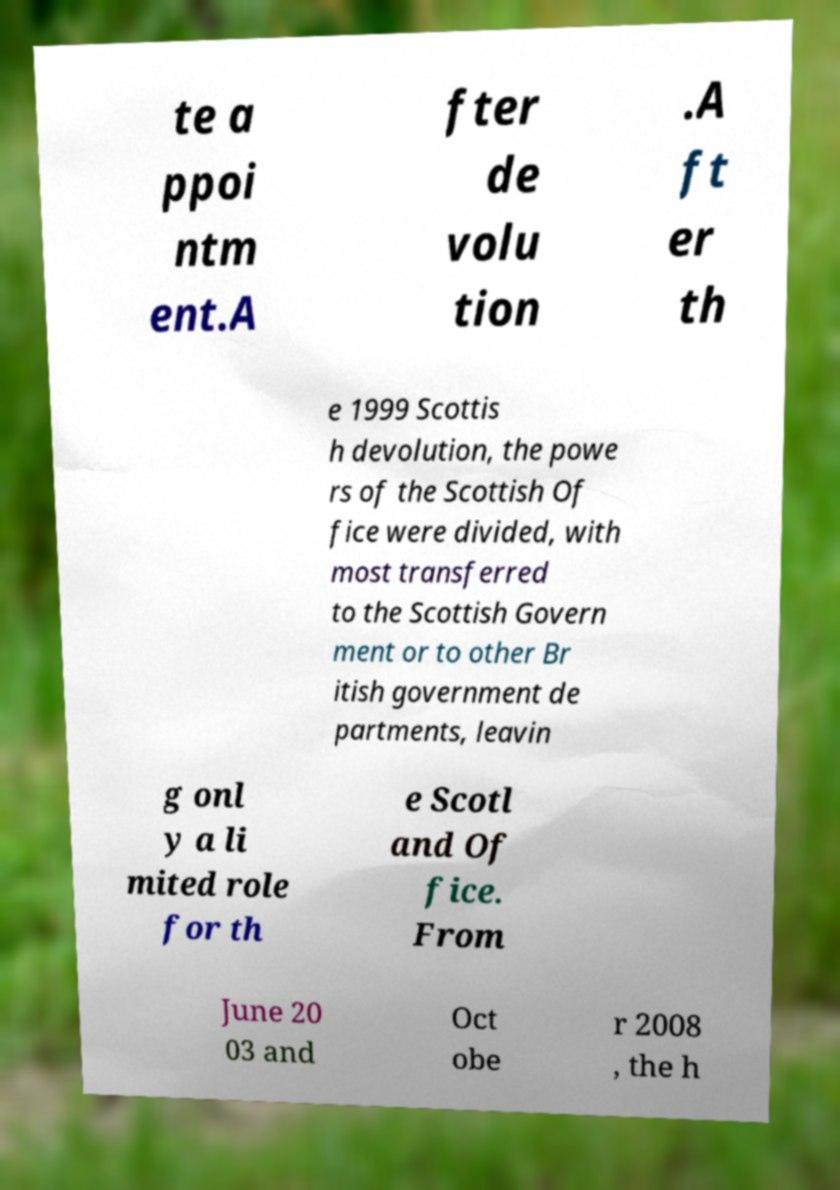Please identify and transcribe the text found in this image. te a ppoi ntm ent.A fter de volu tion .A ft er th e 1999 Scottis h devolution, the powe rs of the Scottish Of fice were divided, with most transferred to the Scottish Govern ment or to other Br itish government de partments, leavin g onl y a li mited role for th e Scotl and Of fice. From June 20 03 and Oct obe r 2008 , the h 